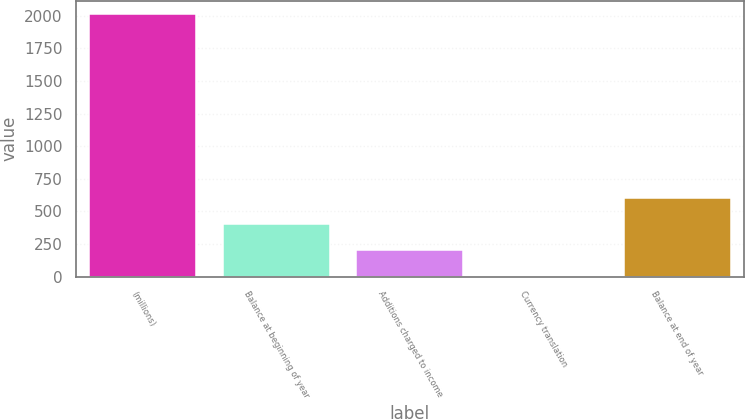Convert chart to OTSL. <chart><loc_0><loc_0><loc_500><loc_500><bar_chart><fcel>(millions)<fcel>Balance at beginning of year<fcel>Additions charged to income<fcel>Currency translation<fcel>Balance at end of year<nl><fcel>2013<fcel>404.2<fcel>203.1<fcel>2<fcel>605.3<nl></chart> 